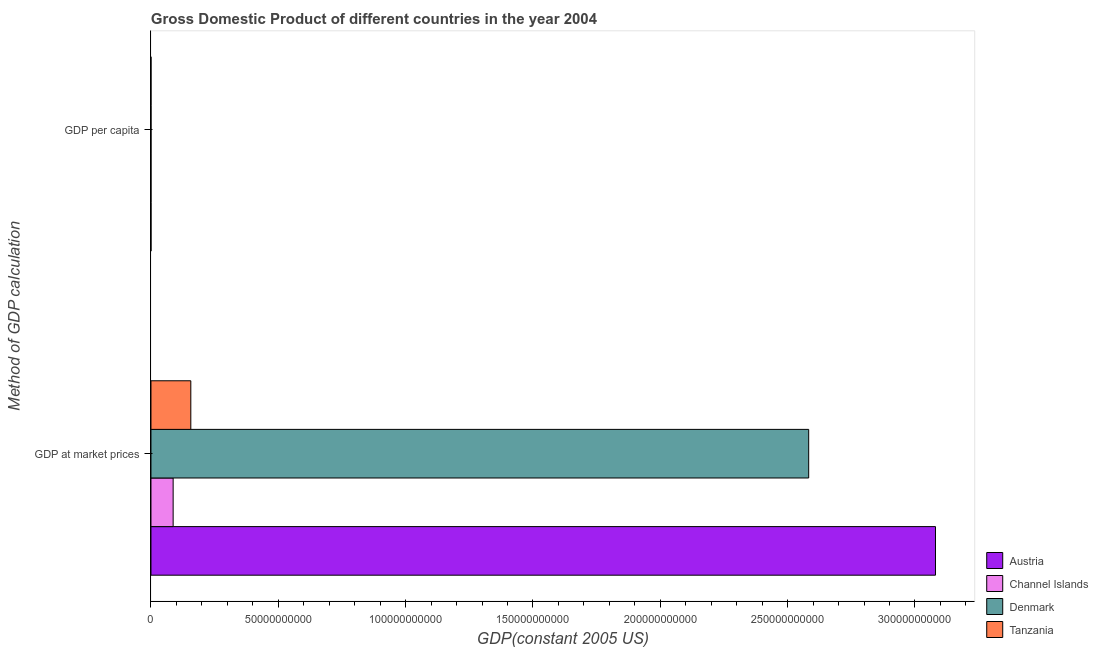How many different coloured bars are there?
Your answer should be compact. 4. How many bars are there on the 2nd tick from the bottom?
Your answer should be very brief. 4. What is the label of the 1st group of bars from the top?
Make the answer very short. GDP per capita. What is the gdp per capita in Channel Islands?
Your answer should be very brief. 5.68e+04. Across all countries, what is the maximum gdp per capita?
Give a very brief answer. 5.68e+04. Across all countries, what is the minimum gdp at market prices?
Your answer should be very brief. 8.71e+09. In which country was the gdp per capita maximum?
Keep it short and to the point. Channel Islands. In which country was the gdp at market prices minimum?
Your answer should be compact. Channel Islands. What is the total gdp at market prices in the graph?
Ensure brevity in your answer.  5.91e+11. What is the difference between the gdp at market prices in Denmark and that in Tanzania?
Your response must be concise. 2.43e+11. What is the difference between the gdp at market prices in Channel Islands and the gdp per capita in Denmark?
Ensure brevity in your answer.  8.71e+09. What is the average gdp per capita per country?
Offer a very short reply. 3.57e+04. What is the difference between the gdp at market prices and gdp per capita in Austria?
Offer a terse response. 3.08e+11. What is the ratio of the gdp per capita in Austria to that in Tanzania?
Offer a terse response. 88.76. In how many countries, is the gdp per capita greater than the average gdp per capita taken over all countries?
Make the answer very short. 3. What does the 4th bar from the top in GDP per capita represents?
Give a very brief answer. Austria. What does the 2nd bar from the bottom in GDP per capita represents?
Make the answer very short. Channel Islands. How many countries are there in the graph?
Offer a very short reply. 4. What is the difference between two consecutive major ticks on the X-axis?
Keep it short and to the point. 5.00e+1. Does the graph contain any zero values?
Your answer should be very brief. No. Does the graph contain grids?
Provide a succinct answer. No. What is the title of the graph?
Give a very brief answer. Gross Domestic Product of different countries in the year 2004. What is the label or title of the X-axis?
Give a very brief answer. GDP(constant 2005 US). What is the label or title of the Y-axis?
Keep it short and to the point. Method of GDP calculation. What is the GDP(constant 2005 US) of Austria in GDP at market prices?
Your answer should be compact. 3.08e+11. What is the GDP(constant 2005 US) of Channel Islands in GDP at market prices?
Give a very brief answer. 8.71e+09. What is the GDP(constant 2005 US) in Denmark in GDP at market prices?
Provide a short and direct response. 2.58e+11. What is the GDP(constant 2005 US) in Tanzania in GDP at market prices?
Offer a very short reply. 1.57e+1. What is the GDP(constant 2005 US) of Austria in GDP per capita?
Your answer should be compact. 3.77e+04. What is the GDP(constant 2005 US) in Channel Islands in GDP per capita?
Offer a very short reply. 5.68e+04. What is the GDP(constant 2005 US) in Denmark in GDP per capita?
Provide a succinct answer. 4.78e+04. What is the GDP(constant 2005 US) of Tanzania in GDP per capita?
Offer a very short reply. 424.71. Across all Method of GDP calculation, what is the maximum GDP(constant 2005 US) in Austria?
Offer a terse response. 3.08e+11. Across all Method of GDP calculation, what is the maximum GDP(constant 2005 US) in Channel Islands?
Provide a succinct answer. 8.71e+09. Across all Method of GDP calculation, what is the maximum GDP(constant 2005 US) of Denmark?
Give a very brief answer. 2.58e+11. Across all Method of GDP calculation, what is the maximum GDP(constant 2005 US) of Tanzania?
Your answer should be very brief. 1.57e+1. Across all Method of GDP calculation, what is the minimum GDP(constant 2005 US) of Austria?
Make the answer very short. 3.77e+04. Across all Method of GDP calculation, what is the minimum GDP(constant 2005 US) of Channel Islands?
Your answer should be very brief. 5.68e+04. Across all Method of GDP calculation, what is the minimum GDP(constant 2005 US) in Denmark?
Keep it short and to the point. 4.78e+04. Across all Method of GDP calculation, what is the minimum GDP(constant 2005 US) of Tanzania?
Make the answer very short. 424.71. What is the total GDP(constant 2005 US) of Austria in the graph?
Provide a succinct answer. 3.08e+11. What is the total GDP(constant 2005 US) in Channel Islands in the graph?
Provide a succinct answer. 8.71e+09. What is the total GDP(constant 2005 US) of Denmark in the graph?
Your answer should be very brief. 2.58e+11. What is the total GDP(constant 2005 US) in Tanzania in the graph?
Make the answer very short. 1.57e+1. What is the difference between the GDP(constant 2005 US) of Austria in GDP at market prices and that in GDP per capita?
Keep it short and to the point. 3.08e+11. What is the difference between the GDP(constant 2005 US) in Channel Islands in GDP at market prices and that in GDP per capita?
Offer a terse response. 8.71e+09. What is the difference between the GDP(constant 2005 US) of Denmark in GDP at market prices and that in GDP per capita?
Offer a very short reply. 2.58e+11. What is the difference between the GDP(constant 2005 US) of Tanzania in GDP at market prices and that in GDP per capita?
Your response must be concise. 1.57e+1. What is the difference between the GDP(constant 2005 US) of Austria in GDP at market prices and the GDP(constant 2005 US) of Channel Islands in GDP per capita?
Your answer should be very brief. 3.08e+11. What is the difference between the GDP(constant 2005 US) in Austria in GDP at market prices and the GDP(constant 2005 US) in Denmark in GDP per capita?
Offer a terse response. 3.08e+11. What is the difference between the GDP(constant 2005 US) of Austria in GDP at market prices and the GDP(constant 2005 US) of Tanzania in GDP per capita?
Ensure brevity in your answer.  3.08e+11. What is the difference between the GDP(constant 2005 US) of Channel Islands in GDP at market prices and the GDP(constant 2005 US) of Denmark in GDP per capita?
Make the answer very short. 8.71e+09. What is the difference between the GDP(constant 2005 US) in Channel Islands in GDP at market prices and the GDP(constant 2005 US) in Tanzania in GDP per capita?
Provide a succinct answer. 8.71e+09. What is the difference between the GDP(constant 2005 US) of Denmark in GDP at market prices and the GDP(constant 2005 US) of Tanzania in GDP per capita?
Make the answer very short. 2.58e+11. What is the average GDP(constant 2005 US) in Austria per Method of GDP calculation?
Your response must be concise. 1.54e+11. What is the average GDP(constant 2005 US) of Channel Islands per Method of GDP calculation?
Provide a succinct answer. 4.35e+09. What is the average GDP(constant 2005 US) in Denmark per Method of GDP calculation?
Your answer should be very brief. 1.29e+11. What is the average GDP(constant 2005 US) of Tanzania per Method of GDP calculation?
Your answer should be compact. 7.83e+09. What is the difference between the GDP(constant 2005 US) of Austria and GDP(constant 2005 US) of Channel Islands in GDP at market prices?
Make the answer very short. 2.99e+11. What is the difference between the GDP(constant 2005 US) of Austria and GDP(constant 2005 US) of Denmark in GDP at market prices?
Offer a terse response. 4.98e+1. What is the difference between the GDP(constant 2005 US) in Austria and GDP(constant 2005 US) in Tanzania in GDP at market prices?
Make the answer very short. 2.92e+11. What is the difference between the GDP(constant 2005 US) of Channel Islands and GDP(constant 2005 US) of Denmark in GDP at market prices?
Keep it short and to the point. -2.50e+11. What is the difference between the GDP(constant 2005 US) of Channel Islands and GDP(constant 2005 US) of Tanzania in GDP at market prices?
Your answer should be compact. -6.94e+09. What is the difference between the GDP(constant 2005 US) in Denmark and GDP(constant 2005 US) in Tanzania in GDP at market prices?
Give a very brief answer. 2.43e+11. What is the difference between the GDP(constant 2005 US) of Austria and GDP(constant 2005 US) of Channel Islands in GDP per capita?
Your answer should be very brief. -1.92e+04. What is the difference between the GDP(constant 2005 US) of Austria and GDP(constant 2005 US) of Denmark in GDP per capita?
Make the answer very short. -1.01e+04. What is the difference between the GDP(constant 2005 US) of Austria and GDP(constant 2005 US) of Tanzania in GDP per capita?
Offer a very short reply. 3.73e+04. What is the difference between the GDP(constant 2005 US) in Channel Islands and GDP(constant 2005 US) in Denmark in GDP per capita?
Your response must be concise. 9060.43. What is the difference between the GDP(constant 2005 US) of Channel Islands and GDP(constant 2005 US) of Tanzania in GDP per capita?
Your response must be concise. 5.64e+04. What is the difference between the GDP(constant 2005 US) in Denmark and GDP(constant 2005 US) in Tanzania in GDP per capita?
Keep it short and to the point. 4.74e+04. What is the ratio of the GDP(constant 2005 US) of Austria in GDP at market prices to that in GDP per capita?
Keep it short and to the point. 8.17e+06. What is the ratio of the GDP(constant 2005 US) of Channel Islands in GDP at market prices to that in GDP per capita?
Your answer should be compact. 1.53e+05. What is the ratio of the GDP(constant 2005 US) in Denmark in GDP at market prices to that in GDP per capita?
Offer a terse response. 5.40e+06. What is the ratio of the GDP(constant 2005 US) of Tanzania in GDP at market prices to that in GDP per capita?
Keep it short and to the point. 3.69e+07. What is the difference between the highest and the second highest GDP(constant 2005 US) of Austria?
Your answer should be compact. 3.08e+11. What is the difference between the highest and the second highest GDP(constant 2005 US) of Channel Islands?
Provide a succinct answer. 8.71e+09. What is the difference between the highest and the second highest GDP(constant 2005 US) of Denmark?
Your response must be concise. 2.58e+11. What is the difference between the highest and the second highest GDP(constant 2005 US) in Tanzania?
Your answer should be very brief. 1.57e+1. What is the difference between the highest and the lowest GDP(constant 2005 US) of Austria?
Your answer should be very brief. 3.08e+11. What is the difference between the highest and the lowest GDP(constant 2005 US) of Channel Islands?
Keep it short and to the point. 8.71e+09. What is the difference between the highest and the lowest GDP(constant 2005 US) of Denmark?
Your answer should be compact. 2.58e+11. What is the difference between the highest and the lowest GDP(constant 2005 US) in Tanzania?
Your answer should be very brief. 1.57e+1. 